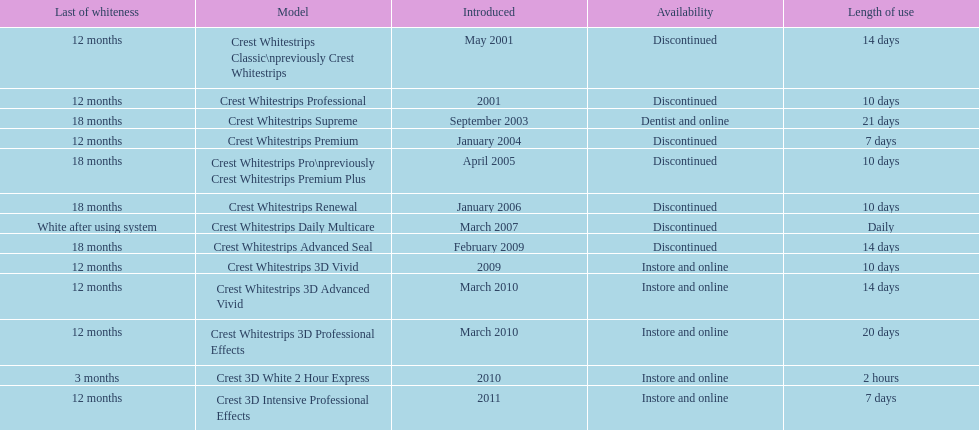Tell me the number of products that give you 12 months of whiteness. 7. 